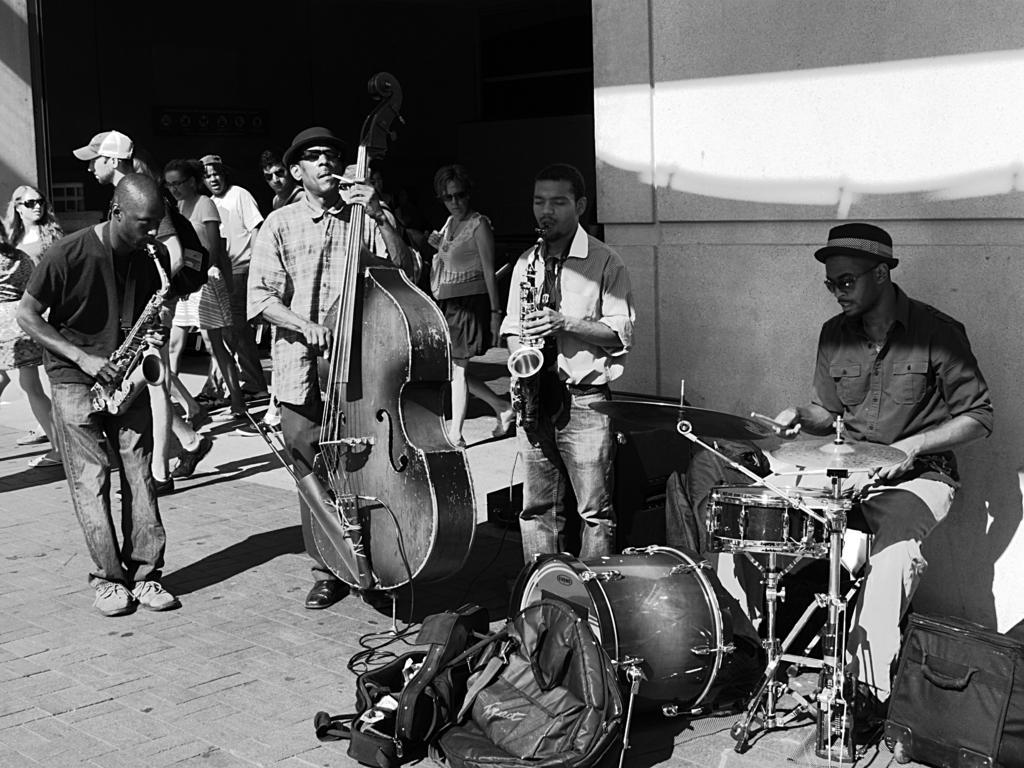Can you describe this image briefly? In this image, there is an outside view. There are some persons wearing clothes and playing musical instruments. There is a drum and three bags in the bottom right of the image. There is a wall on the right of the image. 